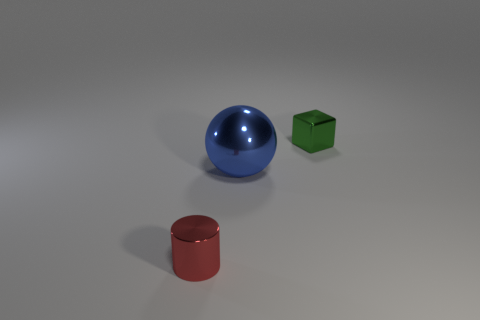How do the different colors of the objects affect the mood or atmosphere of the image? The use of primary colors for these objects creates a simple and visually striking effect. The blue sphere, green cube, and red cylinder provide high contrast against the neutral background, giving the composition a vibrant and playful atmosphere. 